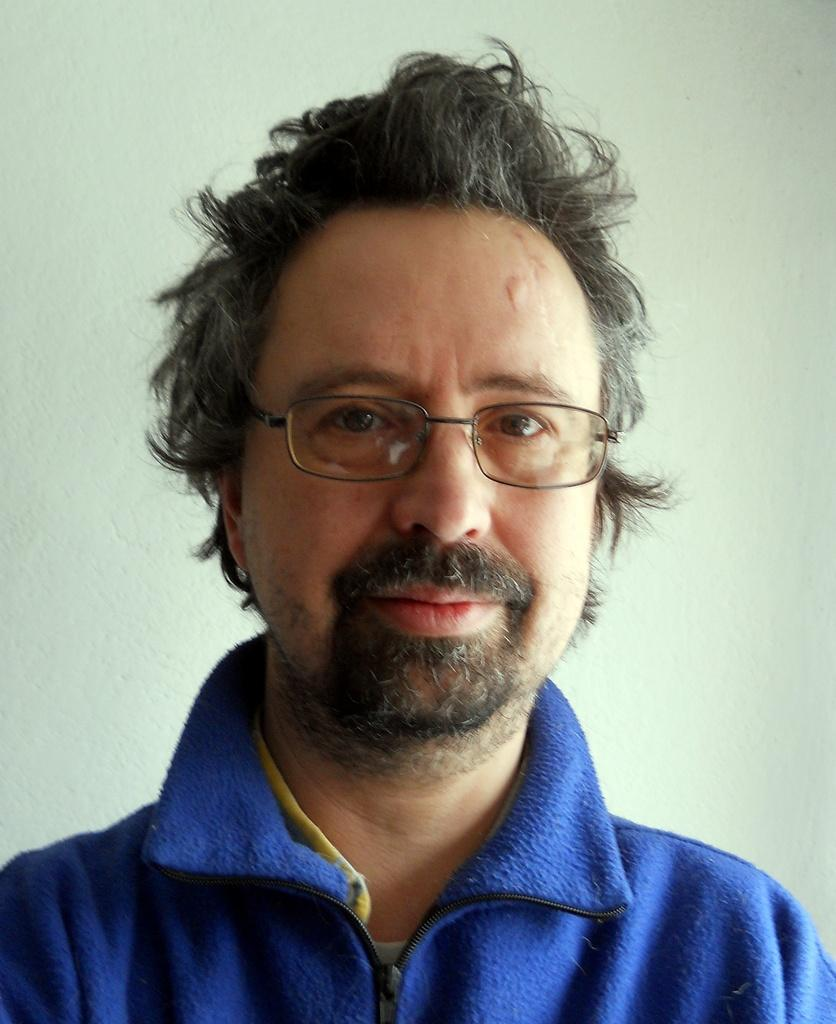Who or what is present in the image? There is a person in the image. What is the person wearing on their upper body? The person is wearing a blue jacket. What type of eyewear is the person wearing? The person is wearing spectacles. What can be seen behind the person in the image? There is a wall in the background of the image. What type of lumber is the person carrying in the image? There is no lumber present in the image; the person is not carrying anything. 